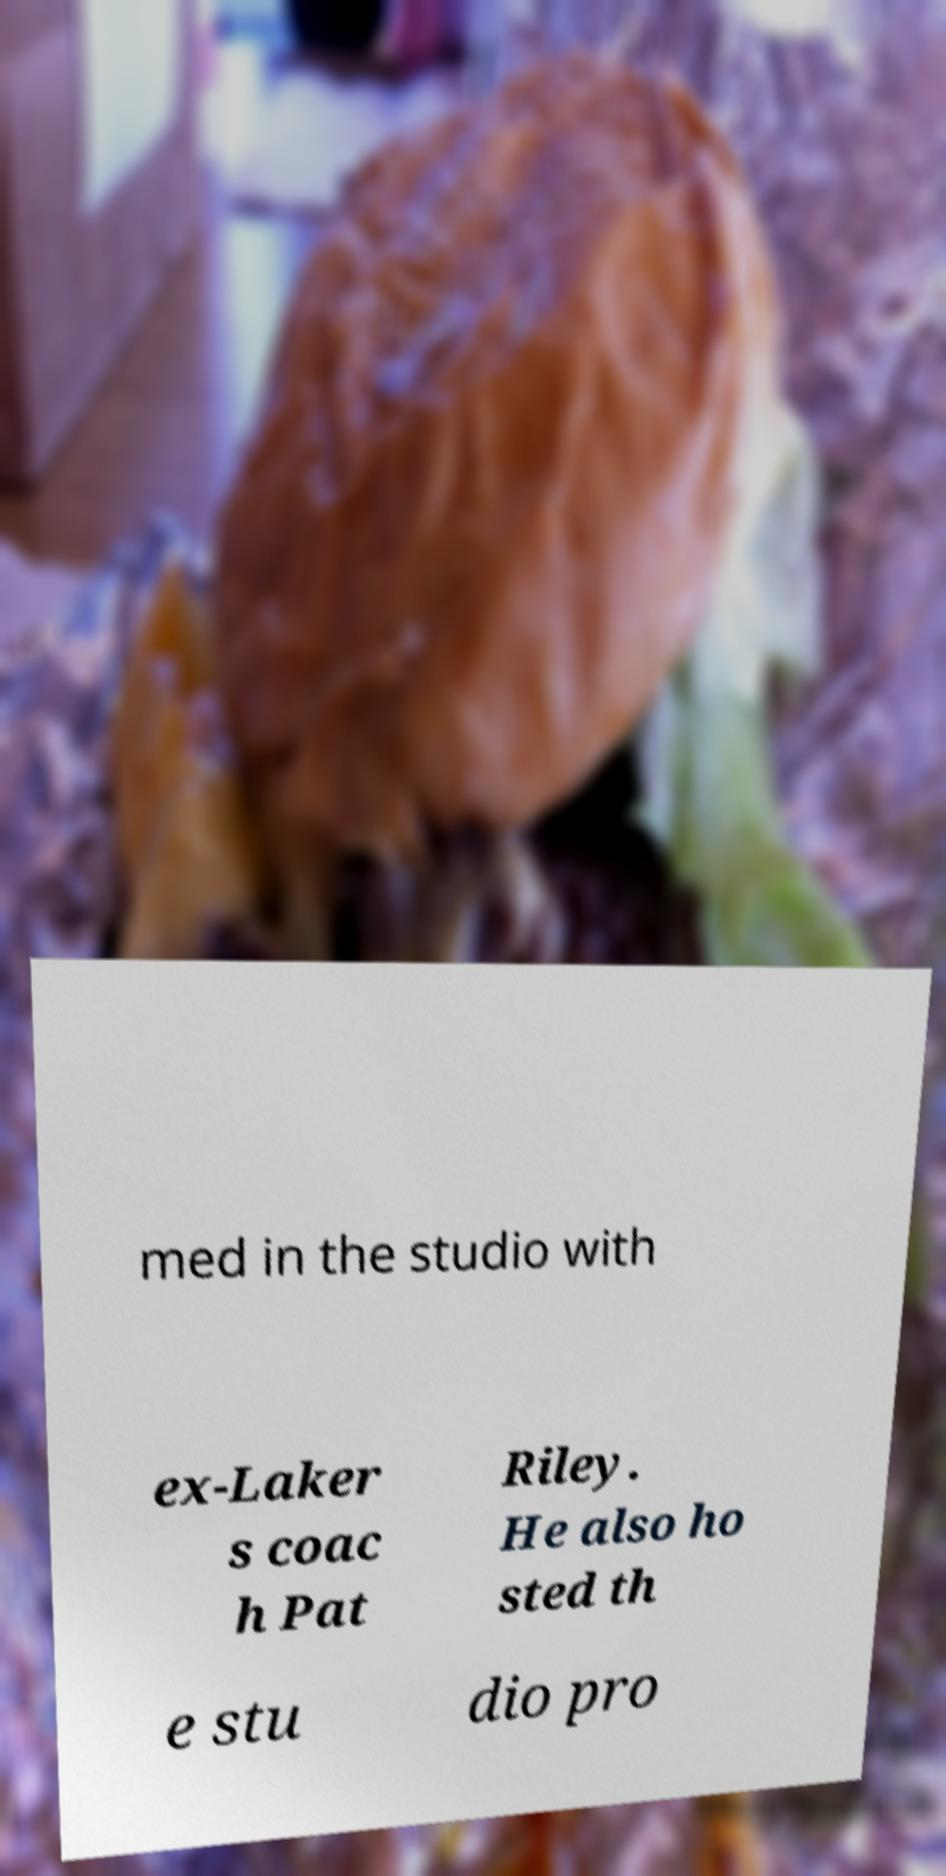I need the written content from this picture converted into text. Can you do that? med in the studio with ex-Laker s coac h Pat Riley. He also ho sted th e stu dio pro 